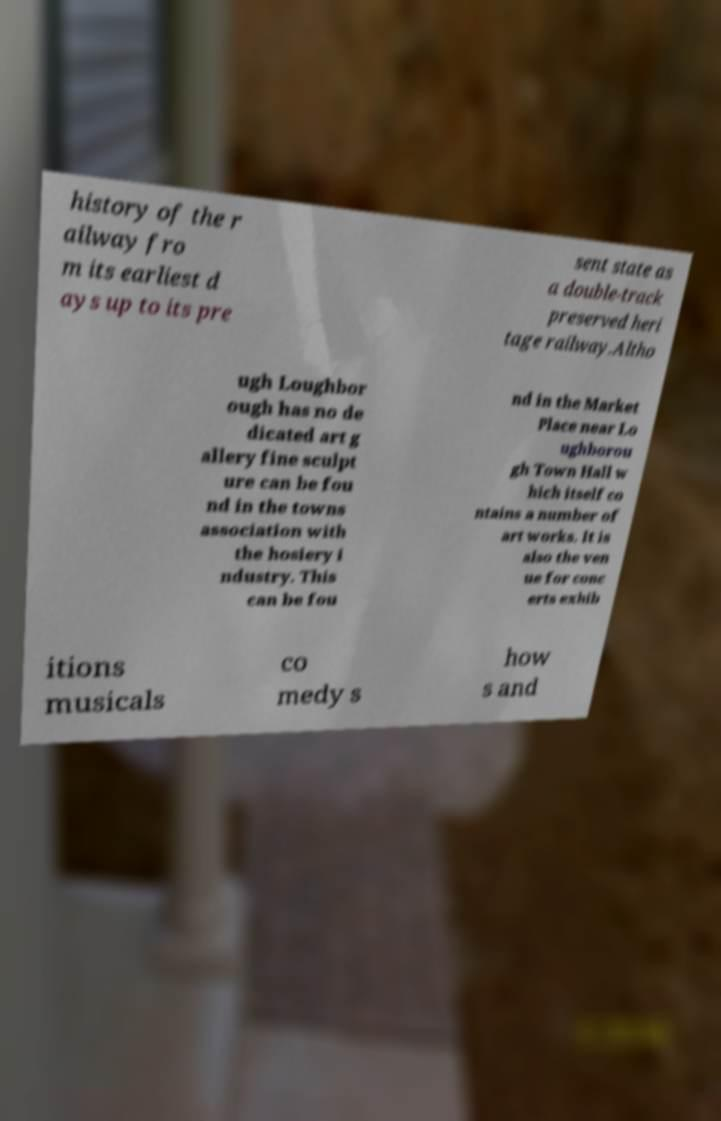Can you read and provide the text displayed in the image?This photo seems to have some interesting text. Can you extract and type it out for me? history of the r ailway fro m its earliest d ays up to its pre sent state as a double-track preserved heri tage railway.Altho ugh Loughbor ough has no de dicated art g allery fine sculpt ure can be fou nd in the towns association with the hosiery i ndustry. This can be fou nd in the Market Place near Lo ughborou gh Town Hall w hich itself co ntains a number of art works. It is also the ven ue for conc erts exhib itions musicals co medy s how s and 